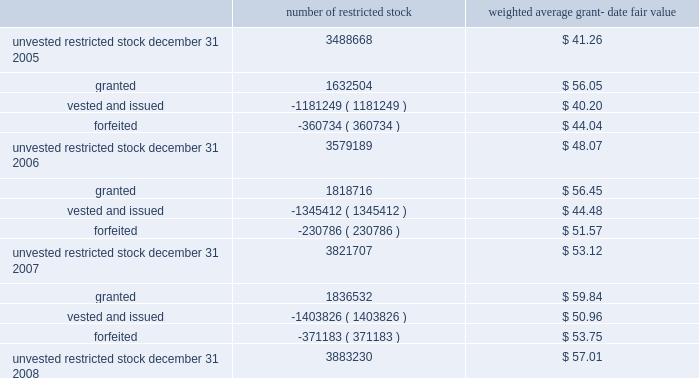N o t e s t o c o n s o l i d a t e d f i n a n c i a l s t a t e m e n t s ( continued ) ace limited and subsidiaries the table shows changes in the company 2019s restricted stock for the years ended december 31 , 2008 , 2007 , and 2006 : number of restricted stock weighted average grant- date fair value .
Under the provisions of fas 123r , the recognition of deferred compensation , a contra-equity account representing the amount of unrecognized restricted stock expense that is reduced as expense is recognized , at the date restricted stock is granted is no longer permitted .
Therefore , upon adoption of fas 123r , the amount of deferred compensation that had been reflected in unearned stock grant compensation was reclassified to additional paid-in capital in the company 2019s consolidated balance sheet .
Restricted stock units the company 2019s 2004 ltip also provides for grants of other awards , including restricted stock units .
The company generally grants restricted stock units with a 4-year vesting period , based on a graded vesting schedule .
Each restricted stock unit repre- sents the company 2019s obligation to deliver to the holder one share of common shares upon vesting .
During 2008 , the company awarded 223588 restricted stock units to officers of the company and its subsidiaries with a weighted-average grant date fair value of $ 59.93 .
During 2007 , 108870 restricted stock units , with a weighted-average grant date fair value of $ 56.29 were awarded to officers of the company and its subsidiaries .
During 2006 , 83370 restricted stock units , with a weighted-average grant date fair value of $ 56.36 were awarded to officers of the company and its subsidiaries .
The company also grants restricted stock units with a 1-year vesting period to non-management directors .
Delivery of common shares on account of these restricted stock units to non-management directors is deferred until six months after the date of the non-management directors 2019 termination from the board .
During 2008 , 2007 , and 2006 , 40362 restricted stock units , 29676 restricted stock units , and 23092 restricted stock units , respectively , were awarded to non-management direc- the espp gives participating employees the right to purchase common shares through payroll deductions during consecutive 201csubscription periods . 201d annual purchases by participants are limited to the number of whole shares that can be purchased by an amount equal to ten percent of the participant 2019s compensation or $ 25000 , whichever is less .
The espp has two six-month subscription periods , the first of which runs between january 1 and june 30 and the second of which runs between july 1 and december 31 of each year .
The amounts that have been collected from participants during a subscription period are used on the 201cexercise date 201d to purchase full shares of common shares .
An exercise date is generally the last trading day of a sub- scription period .
The number of shares purchased is equal to the total amount , as of the exercise date , that has been collected from the participants through payroll deductions for that subscription period , divided by the 201cpurchase price 201d , rounded down to the next full share .
Effective for and from the second subscription period of 2007 , the purchase price is 85 percent of the fair value of a common share on the exercise date .
Prior to the second subscription period of 2007 , the purchase price was calculated as the lower of ( i ) 85 percent of the fair value of a common share on the first day of the subscription period , or .
What is the net change in the number of unvested restricted stocks in 2007? 
Computations: ((1818716 + -1345412) + -230786)
Answer: 242518.0. 